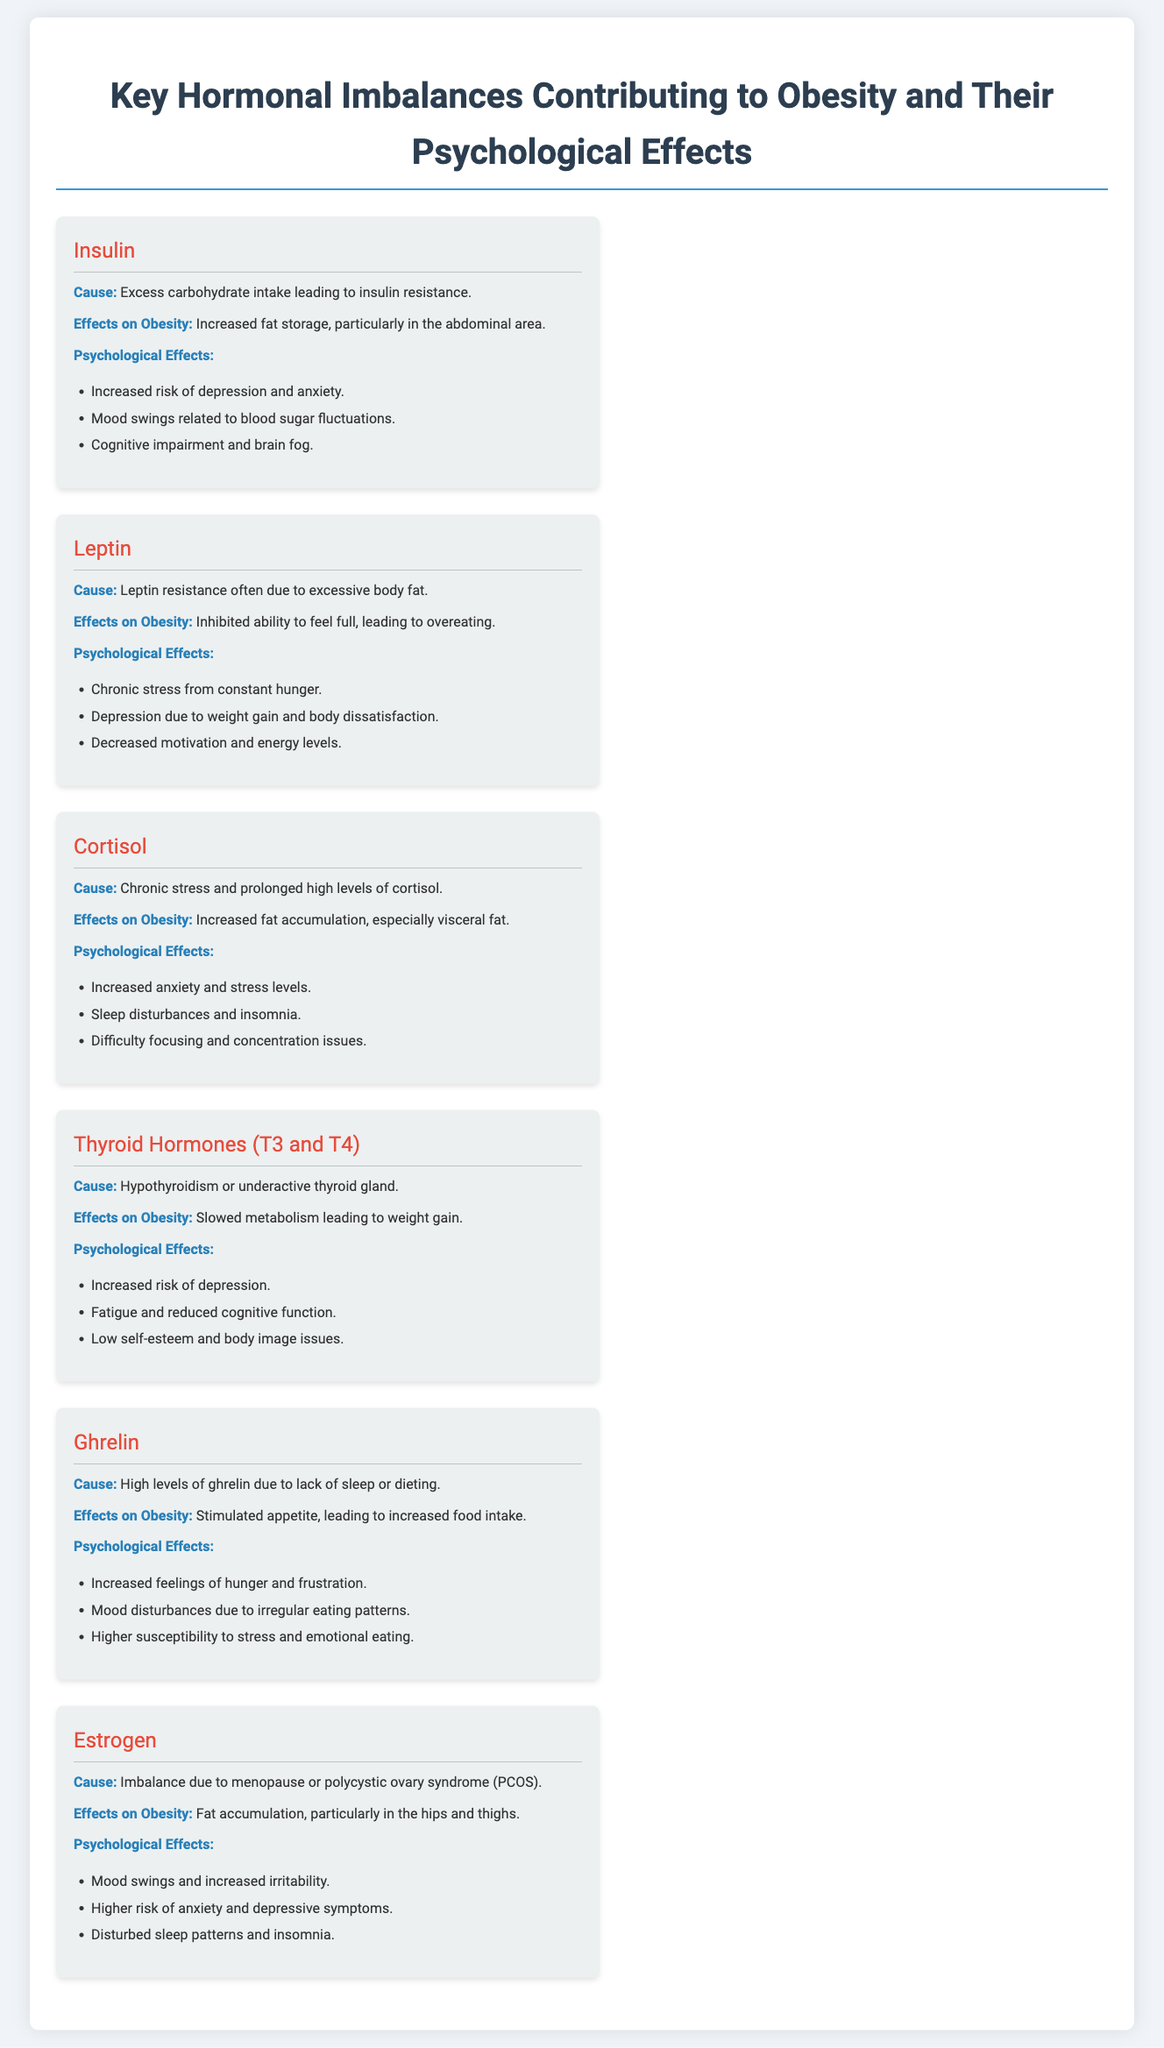What is the cause of Insulin imbalance? The cause of Insulin imbalance is Excess carbohydrate intake leading to insulin resistance.
Answer: Excess carbohydrate intake What psychological effect is associated with excess Cortisol? One psychological effect associated with excess Cortisol is Increased anxiety and stress levels.
Answer: Increased anxiety and stress levels Which hormone is linked to chronic stress from hunger? The hormone linked to chronic stress from hunger is Leptin.
Answer: Leptin What effect does Ghrelin have on appetite? Ghrelin stimulates appetite, leading to increased food intake.
Answer: Stimulated appetite What is the primary cause of Estrogen imbalance? The primary cause of Estrogen imbalance is menopause or polycystic ovary syndrome (PCOS).
Answer: Menopause or PCOS Which hormonal imbalance is associated with sleep disturbances? The hormonal imbalance associated with sleep disturbances is Cortisol.
Answer: Cortisol How many psychological effects are listed for Thyroid Hormones? There are three psychological effects listed for Thyroid Hormones.
Answer: Three What type of fat accumulation is caused by Insulin resistance? Insulin resistance causes Increased fat storage, particularly in the abdominal area.
Answer: Increased fat storage Which hormone is primarily responsible for hunger stimulation due to lack of sleep? The hormone primarily responsible for hunger stimulation due to lack of sleep is Ghrelin.
Answer: Ghrelin What psychological issue can result from Leptin resistance? A psychological issue that can result from Leptin resistance is Depression due to weight gain and body dissatisfaction.
Answer: Depression due to weight gain 